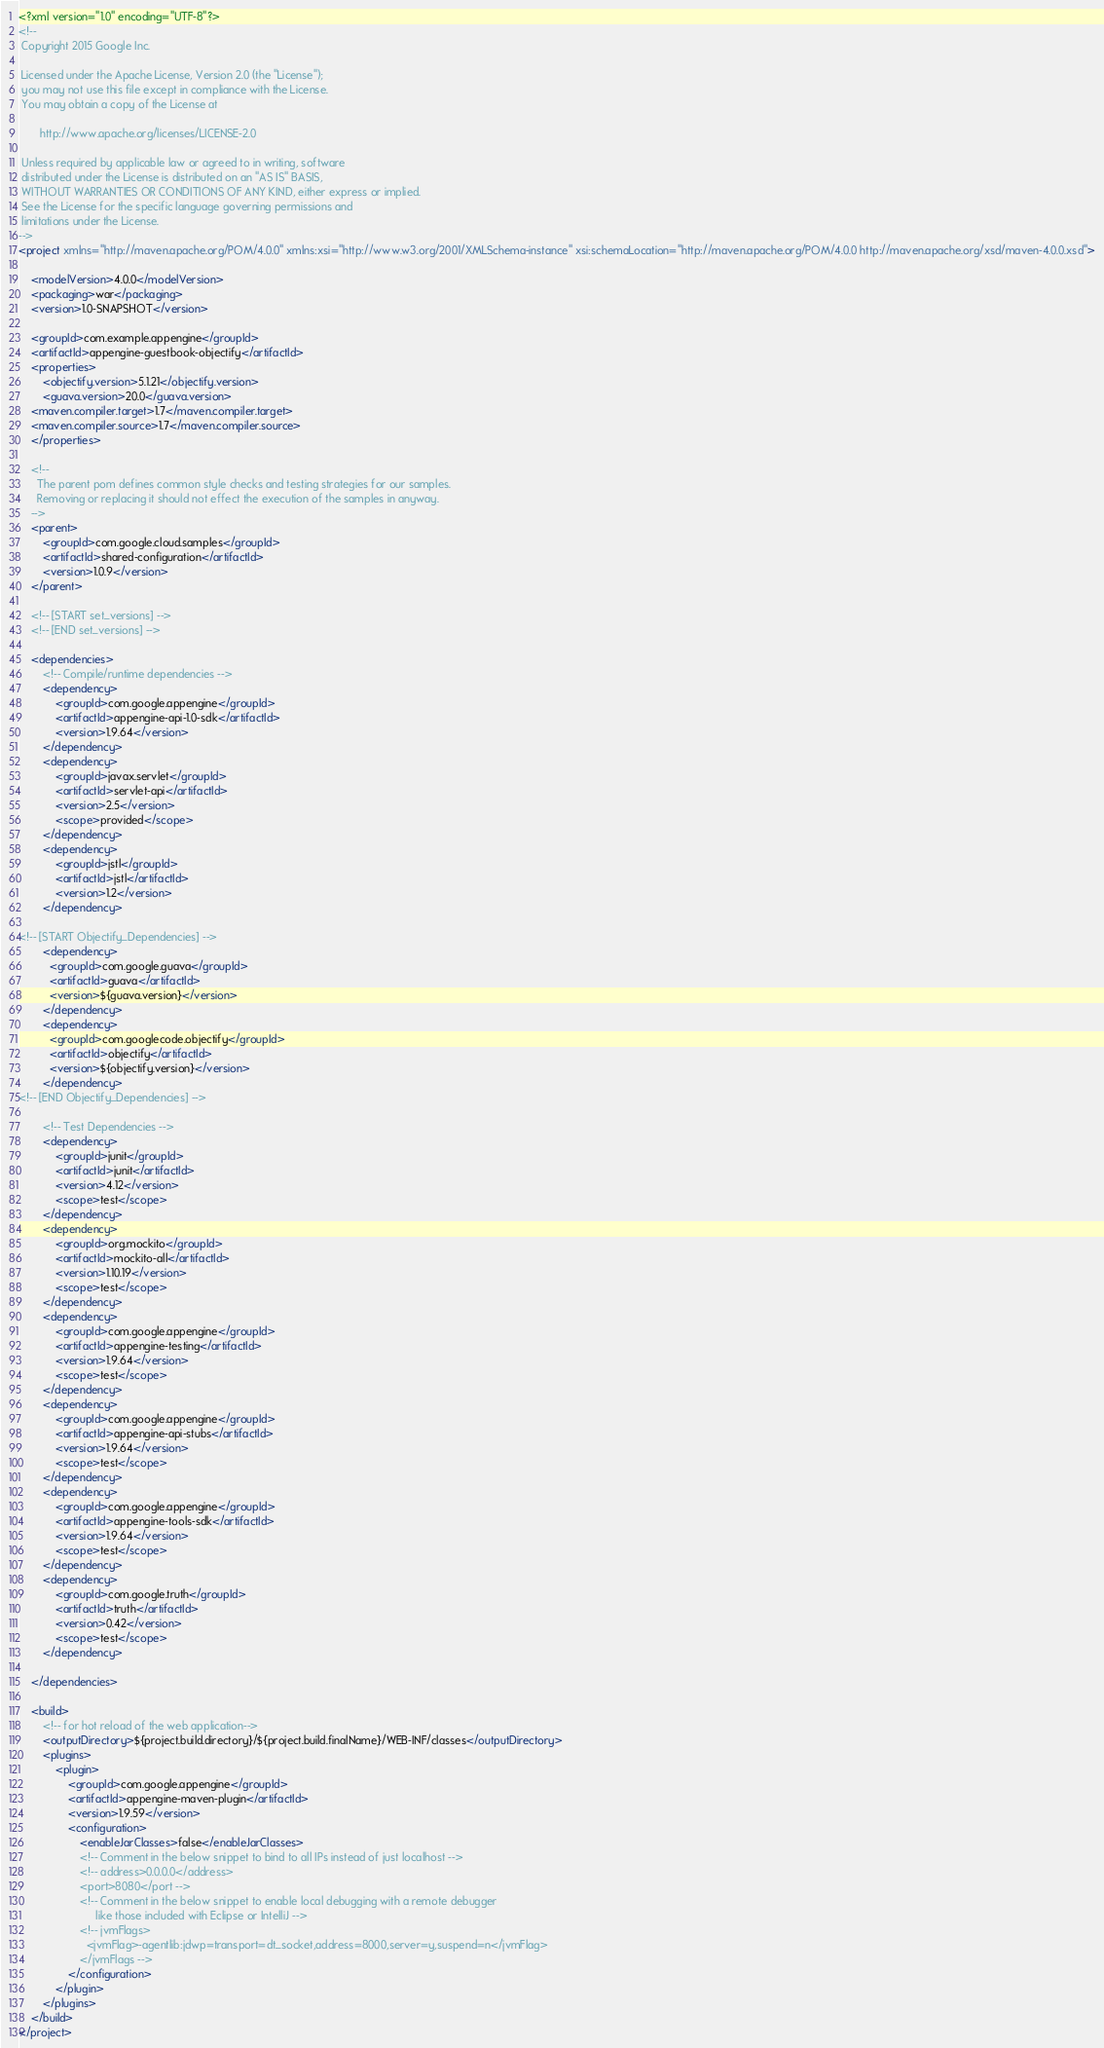<code> <loc_0><loc_0><loc_500><loc_500><_XML_><?xml version="1.0" encoding="UTF-8"?>
<!--
 Copyright 2015 Google Inc.

 Licensed under the Apache License, Version 2.0 (the "License");
 you may not use this file except in compliance with the License.
 You may obtain a copy of the License at

       http://www.apache.org/licenses/LICENSE-2.0

 Unless required by applicable law or agreed to in writing, software
 distributed under the License is distributed on an "AS IS" BASIS,
 WITHOUT WARRANTIES OR CONDITIONS OF ANY KIND, either express or implied.
 See the License for the specific language governing permissions and
 limitations under the License.
-->
<project xmlns="http://maven.apache.org/POM/4.0.0" xmlns:xsi="http://www.w3.org/2001/XMLSchema-instance" xsi:schemaLocation="http://maven.apache.org/POM/4.0.0 http://maven.apache.org/xsd/maven-4.0.0.xsd">

    <modelVersion>4.0.0</modelVersion>
    <packaging>war</packaging>
    <version>1.0-SNAPSHOT</version>

    <groupId>com.example.appengine</groupId>
    <artifactId>appengine-guestbook-objectify</artifactId>
    <properties>
        <objectify.version>5.1.21</objectify.version>
        <guava.version>20.0</guava.version>
    <maven.compiler.target>1.7</maven.compiler.target>
    <maven.compiler.source>1.7</maven.compiler.source>
    </properties>

    <!--
      The parent pom defines common style checks and testing strategies for our samples.
      Removing or replacing it should not effect the execution of the samples in anyway.
    -->
    <parent>
        <groupId>com.google.cloud.samples</groupId>
        <artifactId>shared-configuration</artifactId>
        <version>1.0.9</version>
    </parent>

    <!-- [START set_versions] -->
    <!-- [END set_versions] -->

    <dependencies>
        <!-- Compile/runtime dependencies -->
        <dependency>
            <groupId>com.google.appengine</groupId>
            <artifactId>appengine-api-1.0-sdk</artifactId>
            <version>1.9.64</version>
        </dependency>
        <dependency>
            <groupId>javax.servlet</groupId>
            <artifactId>servlet-api</artifactId>
            <version>2.5</version>
            <scope>provided</scope>
        </dependency>
        <dependency>
            <groupId>jstl</groupId>
            <artifactId>jstl</artifactId>
            <version>1.2</version>
        </dependency>

<!-- [START Objectify_Dependencies] -->
        <dependency>
          <groupId>com.google.guava</groupId>
          <artifactId>guava</artifactId>
          <version>${guava.version}</version>
        </dependency>
        <dependency>
          <groupId>com.googlecode.objectify</groupId>
          <artifactId>objectify</artifactId>
          <version>${objectify.version}</version>
        </dependency>
<!-- [END Objectify_Dependencies] -->

        <!-- Test Dependencies -->
        <dependency>
            <groupId>junit</groupId>
            <artifactId>junit</artifactId>
            <version>4.12</version>
            <scope>test</scope>
        </dependency>
        <dependency>
            <groupId>org.mockito</groupId>
            <artifactId>mockito-all</artifactId>
            <version>1.10.19</version>
            <scope>test</scope>
        </dependency>
        <dependency>
            <groupId>com.google.appengine</groupId>
            <artifactId>appengine-testing</artifactId>
            <version>1.9.64</version>
            <scope>test</scope>
        </dependency>
        <dependency>
            <groupId>com.google.appengine</groupId>
            <artifactId>appengine-api-stubs</artifactId>
            <version>1.9.64</version>
            <scope>test</scope>
        </dependency>
        <dependency>
            <groupId>com.google.appengine</groupId>
            <artifactId>appengine-tools-sdk</artifactId>
            <version>1.9.64</version>
            <scope>test</scope>
        </dependency>
        <dependency>
            <groupId>com.google.truth</groupId>
            <artifactId>truth</artifactId>
            <version>0.42</version>
            <scope>test</scope>
        </dependency>

    </dependencies>

    <build>
        <!-- for hot reload of the web application-->
        <outputDirectory>${project.build.directory}/${project.build.finalName}/WEB-INF/classes</outputDirectory>
        <plugins>
            <plugin>
                <groupId>com.google.appengine</groupId>
                <artifactId>appengine-maven-plugin</artifactId>
                <version>1.9.59</version>
                <configuration>
                    <enableJarClasses>false</enableJarClasses>
                    <!-- Comment in the below snippet to bind to all IPs instead of just localhost -->
                    <!-- address>0.0.0.0</address>
                    <port>8080</port -->
                    <!-- Comment in the below snippet to enable local debugging with a remote debugger
                         like those included with Eclipse or IntelliJ -->
                    <!-- jvmFlags>
                      <jvmFlag>-agentlib:jdwp=transport=dt_socket,address=8000,server=y,suspend=n</jvmFlag>
                    </jvmFlags -->
                </configuration>
            </plugin>
        </plugins>
    </build>
</project>
</code> 